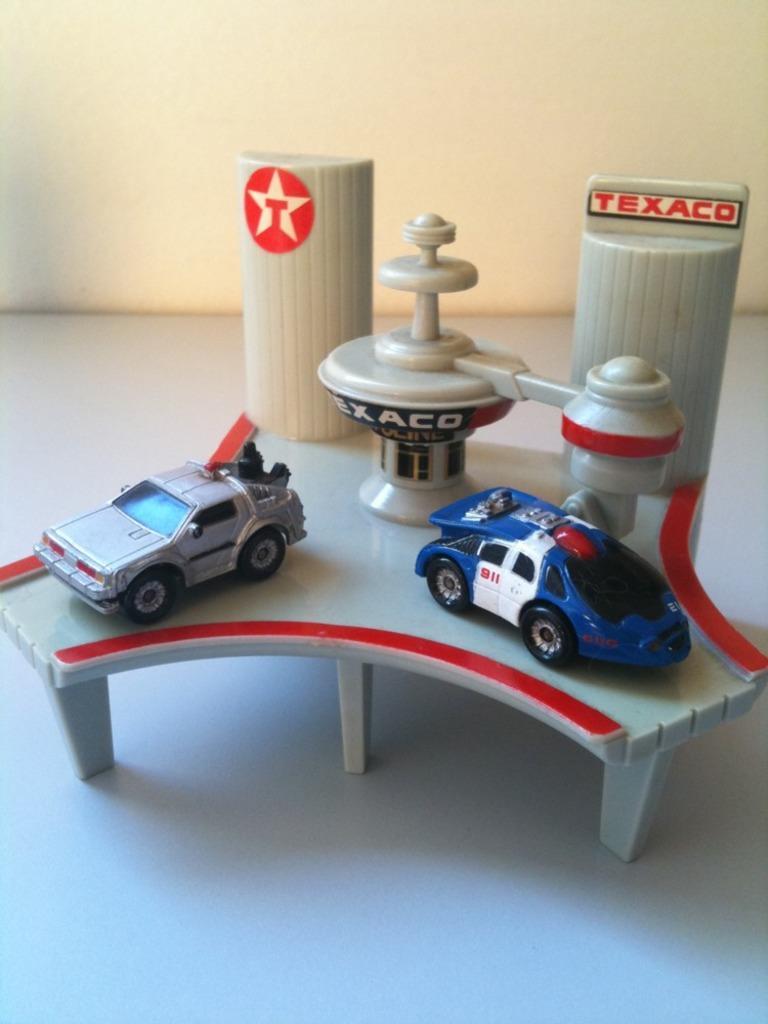Please provide a concise description of this image. This image consists of toys. In the front, there are two cars. At the bottom, there is a floor. In the background, there is a wall. 